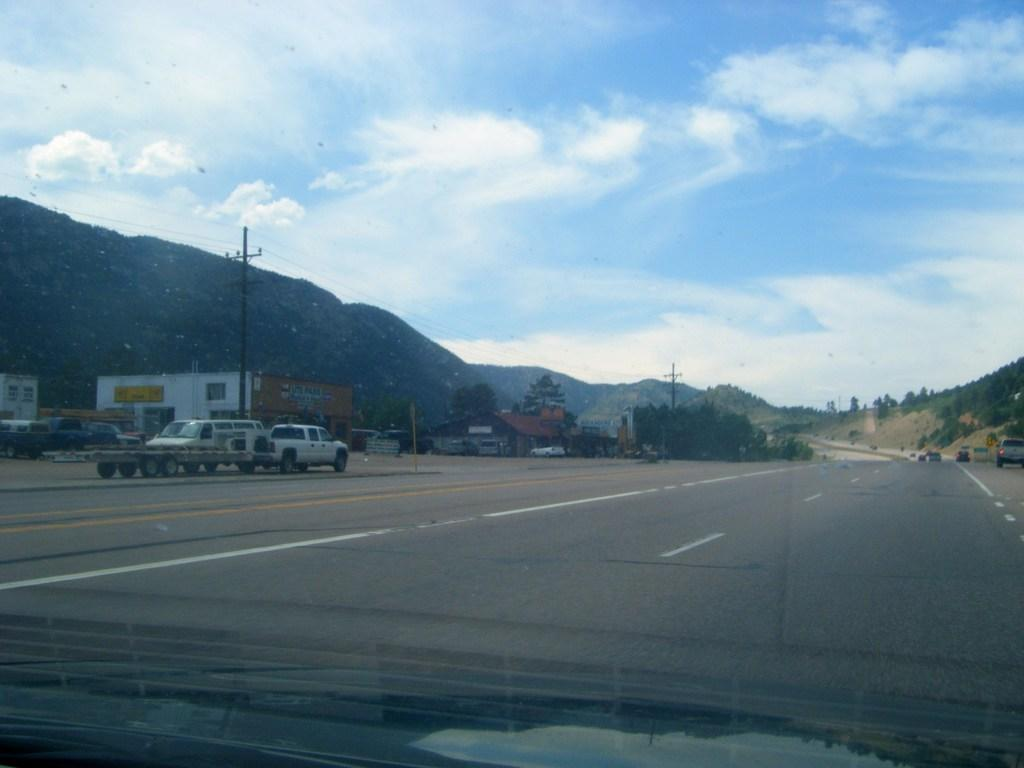What is the main feature of the image? There is a road in the image. What can be seen on the left side of the road? There are cars on the left side of the image. What structures are present alongside the road? There are electric poles in the image. What type of vegetation is visible in the image? There are trees in the image. What is visible at the top of the image? The sky is visible at the top of the image. What type of calendar is hanging on the electric pole in the image? There is no calendar present in the image; it only features a road, cars, electric poles, trees, and the sky. How many mint leaves can be seen on the road in the image? There are no mint leaves present in the image; it only features a road, cars, electric poles, trees, and the sky. 